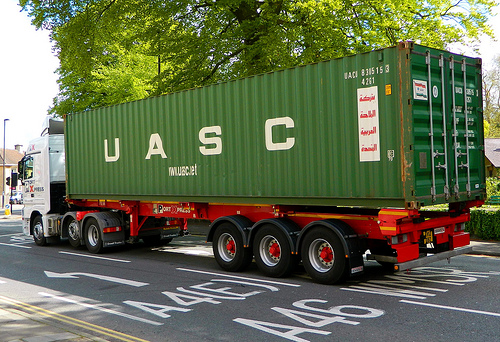If you could animate the elements in the image, what story would they tell? Animating the elements, the story might focus on the journey of the truck driver who is transporting essential goods across various cities. The container could be equipped with smart logistics tech, showing real-time data on its status and contents. Along the way, it passes through picturesque and bustling urban landscapes, highlighting the intersection of technology and nature. Can you describe a day in the life of the truck driver seen in the image? The truck driver's day starts early, performing a thorough check of the vehicle and its cargo. Every day, they navigate through different terrains and weather conditions, ensuring timely and safe delivery of the goods. They make periodic stops for rest and refueling, interacting with various customers upon delivery. At the end of the day, they keep records of the inventory and prepare for the next journey, enjoying a sense of accomplishment for the miles covered and goods delivered. 